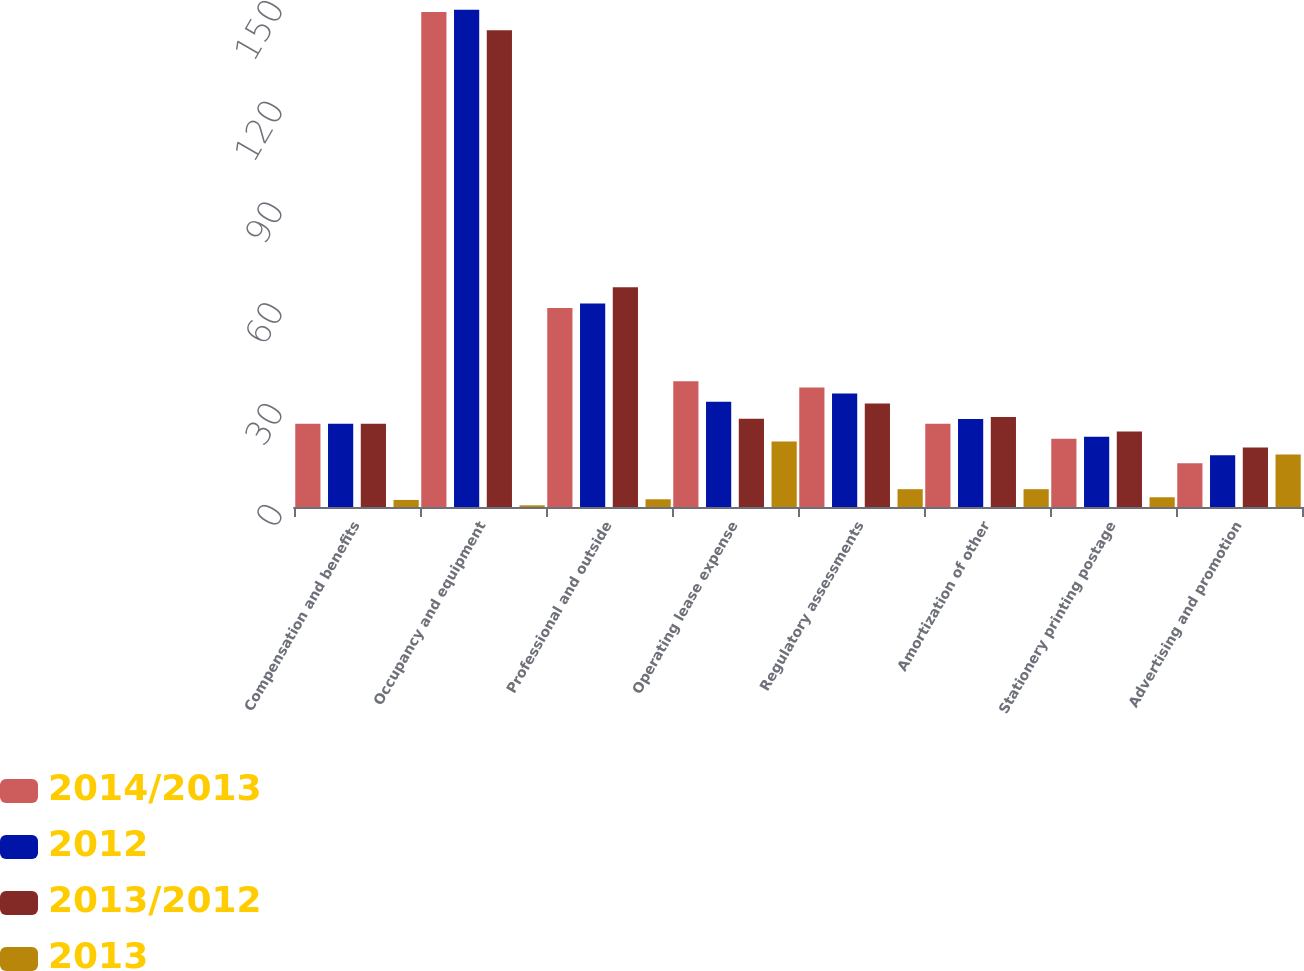<chart> <loc_0><loc_0><loc_500><loc_500><stacked_bar_chart><ecel><fcel>Compensation and benefits<fcel>Occupancy and equipment<fcel>Professional and outside<fcel>Operating lease expense<fcel>Regulatory assessments<fcel>Amortization of other<fcel>Stationery printing postage<fcel>Advertising and promotion<nl><fcel>2014/2013<fcel>24.8<fcel>147.3<fcel>59.2<fcel>37.4<fcel>35.6<fcel>24.8<fcel>20.3<fcel>13<nl><fcel>2012<fcel>24.8<fcel>148<fcel>60.6<fcel>31.3<fcel>33.8<fcel>26.2<fcel>20.9<fcel>15.4<nl><fcel>2013/2012<fcel>24.8<fcel>141.9<fcel>65.4<fcel>26.3<fcel>30.8<fcel>26.8<fcel>22.5<fcel>17.7<nl><fcel>2013<fcel>2.1<fcel>0.5<fcel>2.3<fcel>19.5<fcel>5.3<fcel>5.3<fcel>2.9<fcel>15.6<nl></chart> 